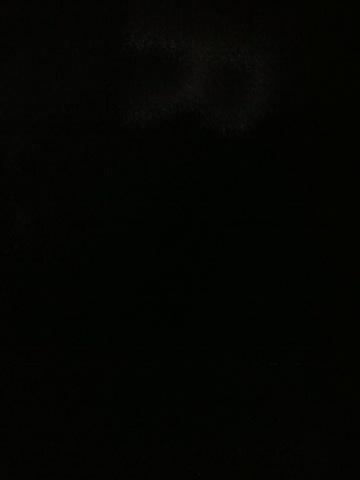Create a realistic scenario of what this dark image could be capturing in a long response. This image could realistically be capturing a night scene in a remote, rural area. Far from the reach of artificial lights, the landscape is blanketed in darkness. Perhaps it's the edge of a dense forest, so thick with foliage that even the moonlight struggles to penetrate. This setting could be home to nocturnal wildlife, their movements and sounds barely perceptible in the still, quiet night. The blackness is almost palpable, offering a rare and profound sense of solitude and connection with the primal rhythms of nature. 